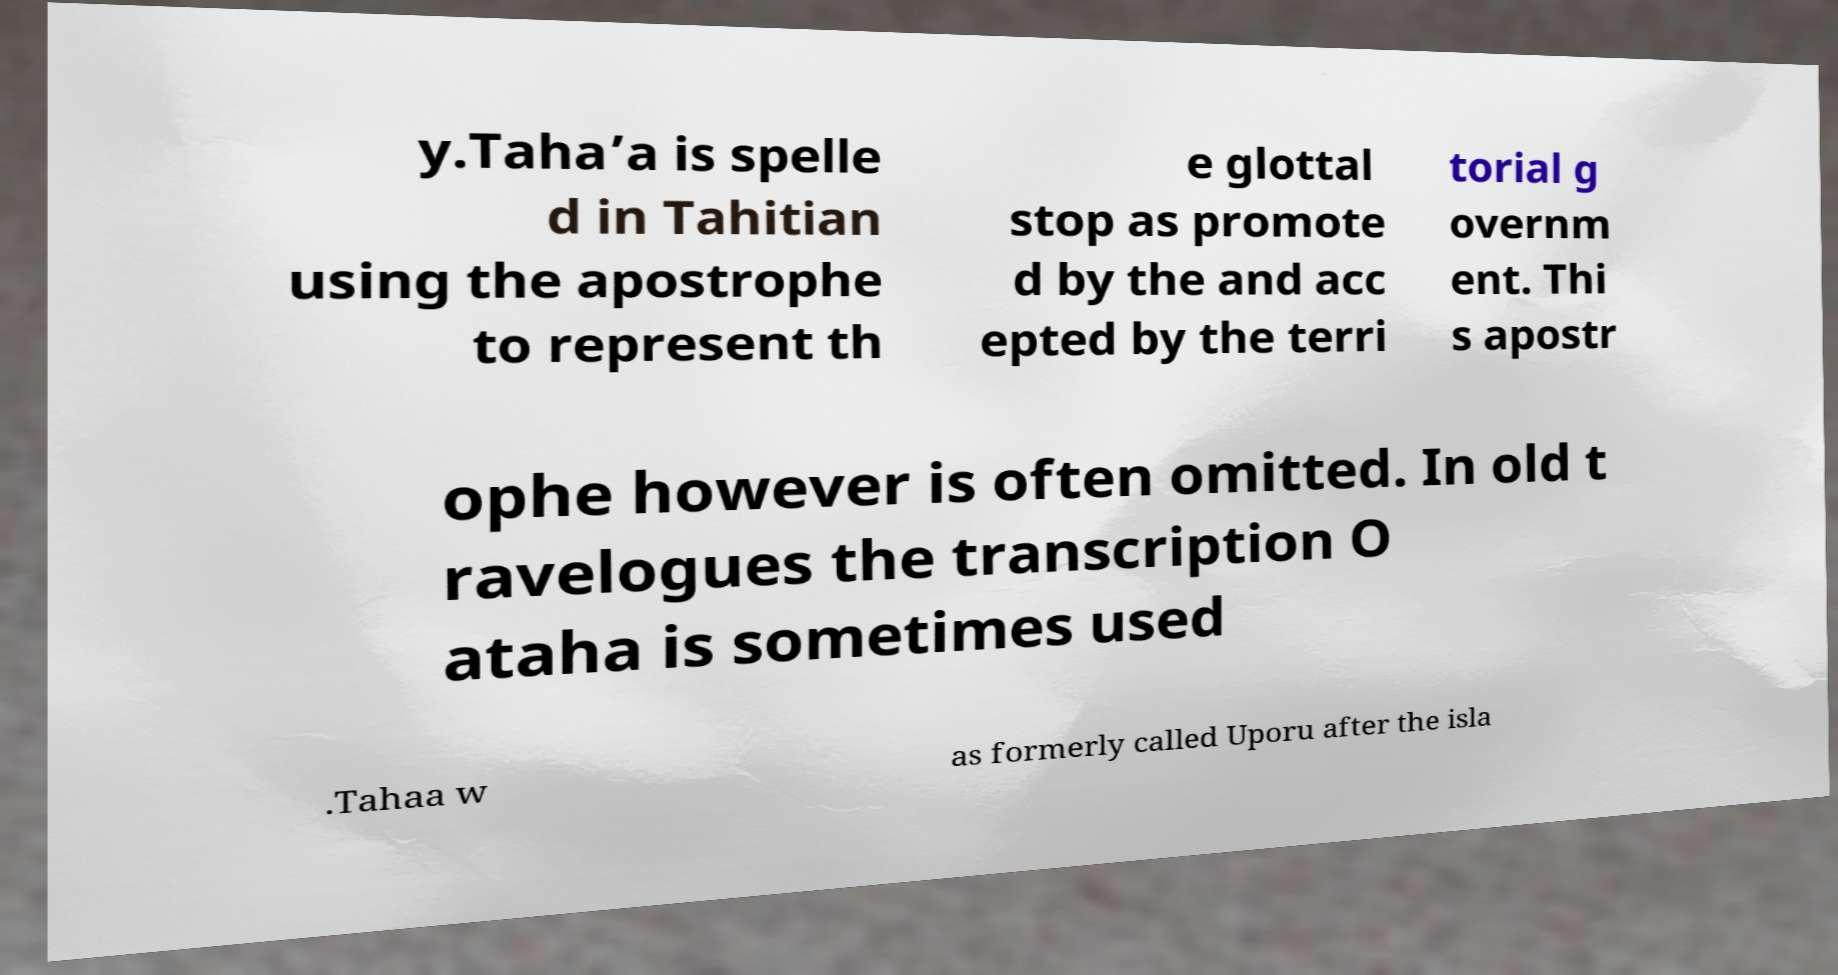Please read and relay the text visible in this image. What does it say? y.Taha’a is spelle d in Tahitian using the apostrophe to represent th e glottal stop as promote d by the and acc epted by the terri torial g overnm ent. Thi s apostr ophe however is often omitted. In old t ravelogues the transcription O ataha is sometimes used .Tahaa w as formerly called Uporu after the isla 